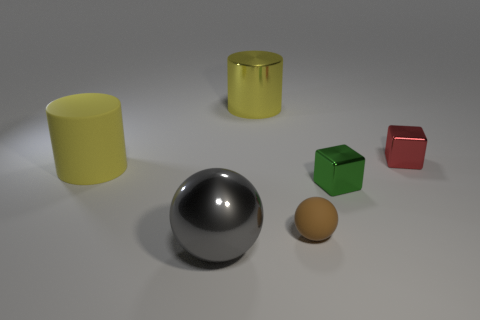Add 2 small brown matte spheres. How many objects exist? 8 Subtract all balls. How many objects are left? 4 Add 4 tiny brown balls. How many tiny brown balls are left? 5 Add 5 tiny red shiny blocks. How many tiny red shiny blocks exist? 6 Subtract 0 cyan spheres. How many objects are left? 6 Subtract all big gray shiny balls. Subtract all yellow cylinders. How many objects are left? 3 